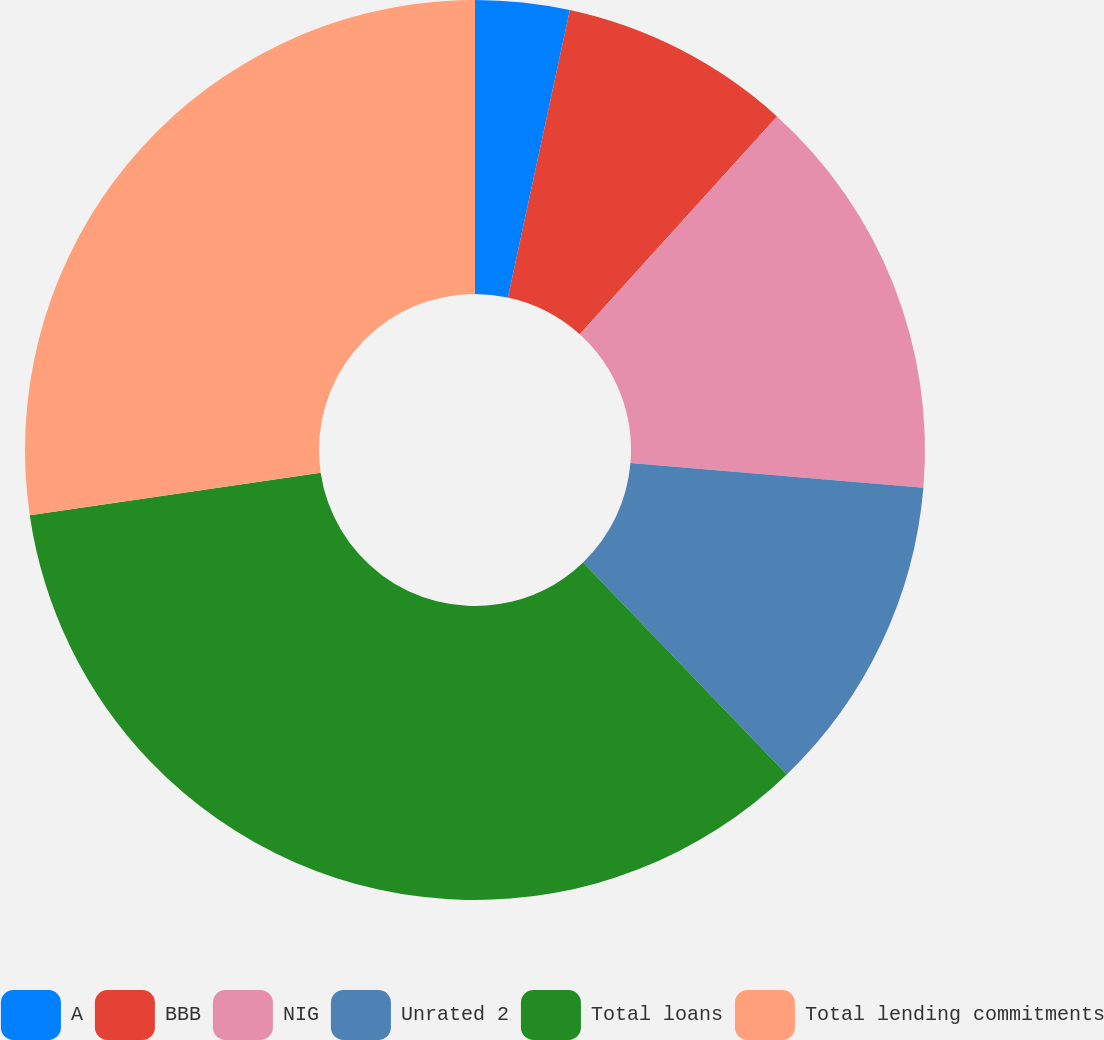Convert chart to OTSL. <chart><loc_0><loc_0><loc_500><loc_500><pie_chart><fcel>A<fcel>BBB<fcel>NIG<fcel>Unrated 2<fcel>Total loans<fcel>Total lending commitments<nl><fcel>3.38%<fcel>8.33%<fcel>14.63%<fcel>11.48%<fcel>34.87%<fcel>27.32%<nl></chart> 